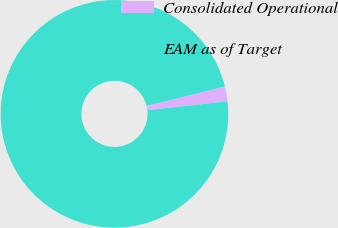Convert chart to OTSL. <chart><loc_0><loc_0><loc_500><loc_500><pie_chart><fcel>Consolidated Operational<fcel>EAM as of Target<nl><fcel>2.1%<fcel>97.9%<nl></chart> 